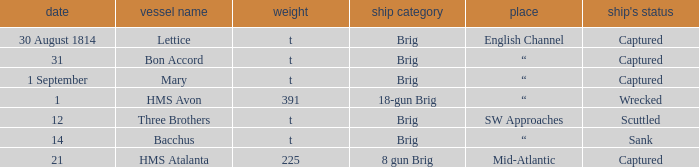The ship named Bacchus with a tonnage of t had what disposition of ship? Sank. 